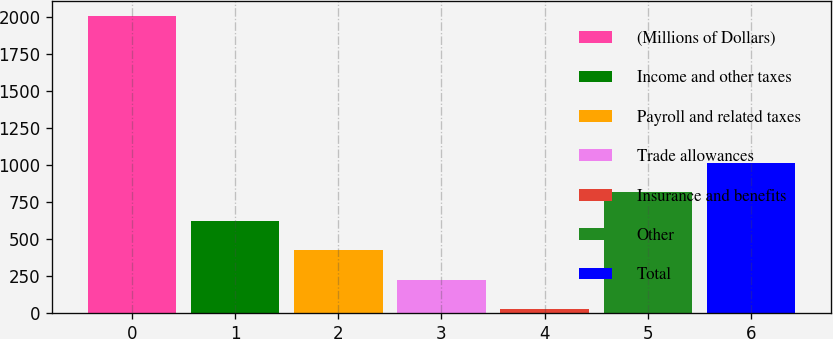Convert chart to OTSL. <chart><loc_0><loc_0><loc_500><loc_500><bar_chart><fcel>(Millions of Dollars)<fcel>Income and other taxes<fcel>Payroll and related taxes<fcel>Trade allowances<fcel>Insurance and benefits<fcel>Other<fcel>Total<nl><fcel>2004<fcel>619.47<fcel>421.68<fcel>223.89<fcel>26.1<fcel>817.26<fcel>1015.05<nl></chart> 